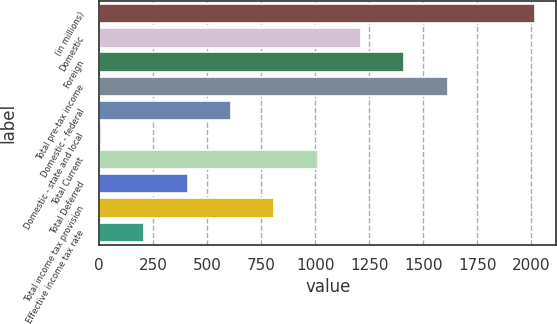<chart> <loc_0><loc_0><loc_500><loc_500><bar_chart><fcel>(in millions)<fcel>Domestic<fcel>Foreign<fcel>Total pre-tax income<fcel>Domestic - federal<fcel>Domestic - state and local<fcel>Total Current<fcel>Total Deferred<fcel>Total income tax provision<fcel>Effective income tax rate<nl><fcel>2014<fcel>1211.2<fcel>1411.9<fcel>1612.6<fcel>609.1<fcel>7<fcel>1010.5<fcel>408.4<fcel>809.8<fcel>207.7<nl></chart> 